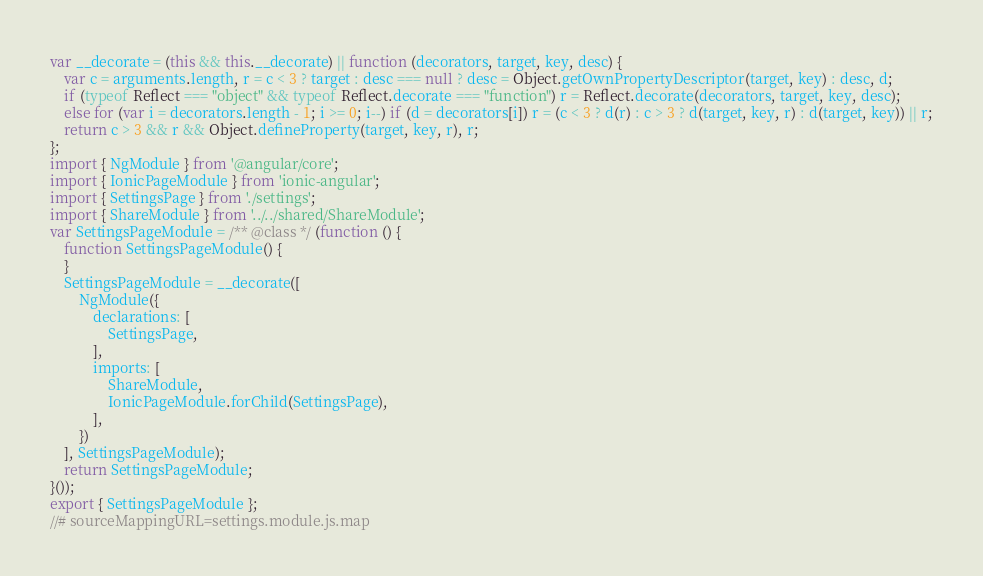<code> <loc_0><loc_0><loc_500><loc_500><_JavaScript_>var __decorate = (this && this.__decorate) || function (decorators, target, key, desc) {
    var c = arguments.length, r = c < 3 ? target : desc === null ? desc = Object.getOwnPropertyDescriptor(target, key) : desc, d;
    if (typeof Reflect === "object" && typeof Reflect.decorate === "function") r = Reflect.decorate(decorators, target, key, desc);
    else for (var i = decorators.length - 1; i >= 0; i--) if (d = decorators[i]) r = (c < 3 ? d(r) : c > 3 ? d(target, key, r) : d(target, key)) || r;
    return c > 3 && r && Object.defineProperty(target, key, r), r;
};
import { NgModule } from '@angular/core';
import { IonicPageModule } from 'ionic-angular';
import { SettingsPage } from './settings';
import { ShareModule } from '../../shared/ShareModule';
var SettingsPageModule = /** @class */ (function () {
    function SettingsPageModule() {
    }
    SettingsPageModule = __decorate([
        NgModule({
            declarations: [
                SettingsPage,
            ],
            imports: [
                ShareModule,
                IonicPageModule.forChild(SettingsPage),
            ],
        })
    ], SettingsPageModule);
    return SettingsPageModule;
}());
export { SettingsPageModule };
//# sourceMappingURL=settings.module.js.map</code> 